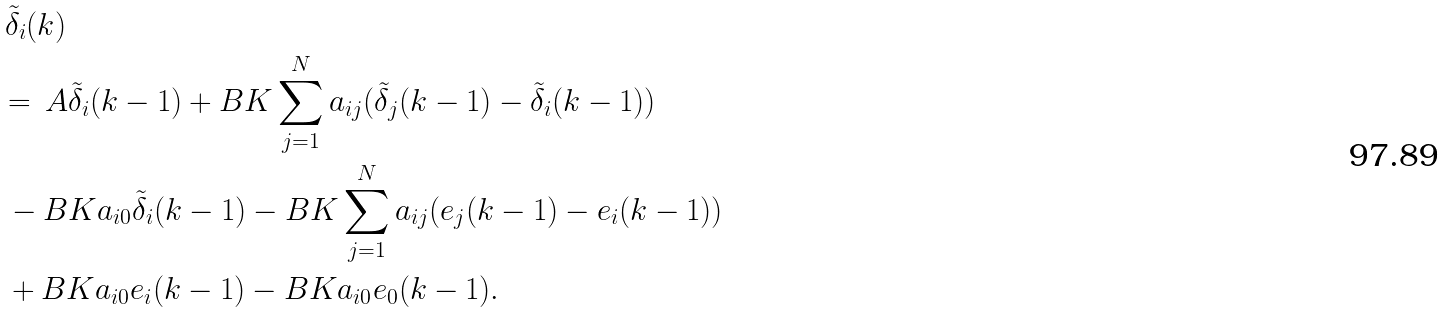Convert formula to latex. <formula><loc_0><loc_0><loc_500><loc_500>& \, \tilde { \delta } _ { i } ( k ) \\ & = \, A \tilde { \delta } _ { i } ( k - 1 ) + B K \sum _ { j = 1 } ^ { N } a _ { i j } ( \tilde { \delta } _ { j } ( k - 1 ) - \tilde { \delta } _ { i } ( k - 1 ) ) \\ & \, - B K a _ { i 0 } \tilde { \delta } _ { i } ( k - 1 ) - B K \sum _ { j = 1 } ^ { N } a _ { i j } ( e _ { j } ( k - 1 ) - e _ { i } ( k - 1 ) ) \\ & \, + B K a _ { i 0 } e _ { i } ( k - 1 ) - B K a _ { i 0 } e _ { 0 } ( k - 1 ) .</formula> 